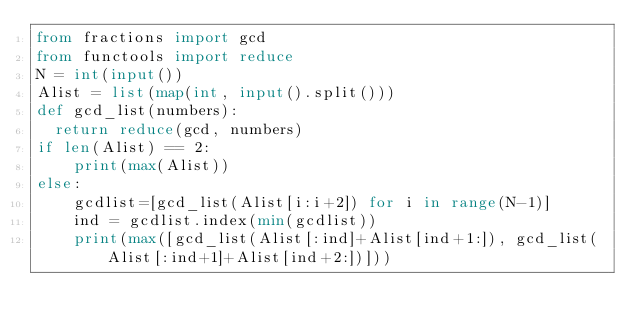Convert code to text. <code><loc_0><loc_0><loc_500><loc_500><_Python_>from fractions import gcd
from functools import reduce
N = int(input())
Alist = list(map(int, input().split()))
def gcd_list(numbers):
  return reduce(gcd, numbers)
if len(Alist) == 2:
    print(max(Alist))
else:
    gcdlist=[gcd_list(Alist[i:i+2]) for i in range(N-1)]
    ind = gcdlist.index(min(gcdlist))
    print(max([gcd_list(Alist[:ind]+Alist[ind+1:]), gcd_list(Alist[:ind+1]+Alist[ind+2:])]))</code> 